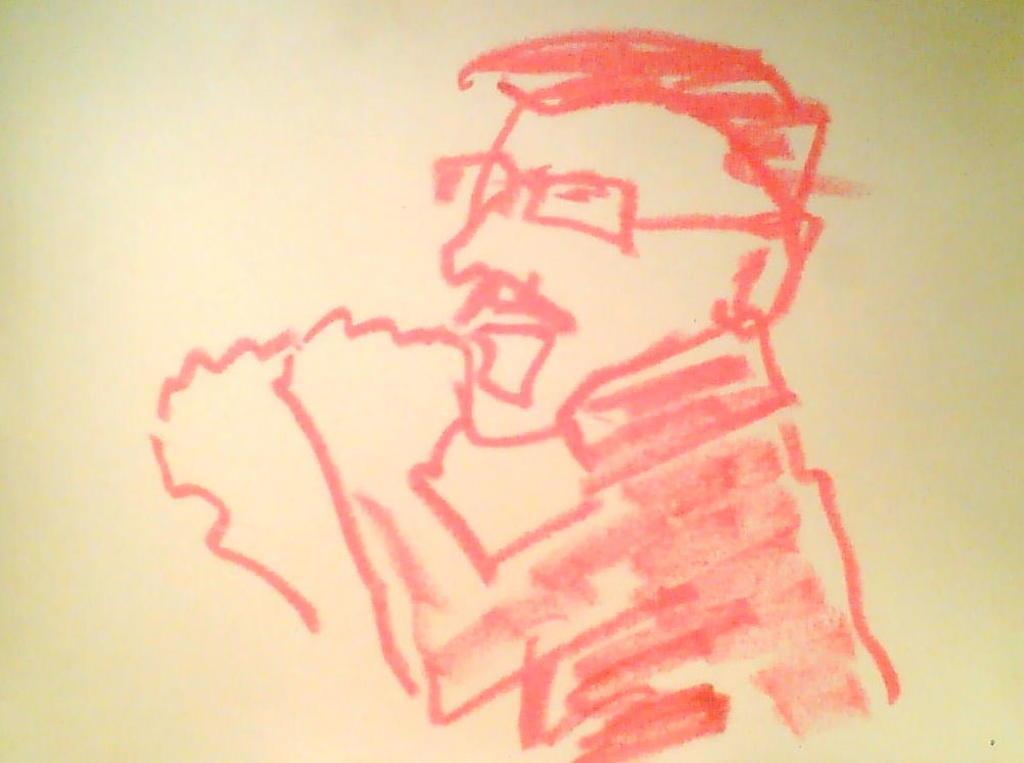In one or two sentences, can you explain what this image depicts? In this image I can see the sketch of the person and the sketch is in red color and I can see the white color background. 